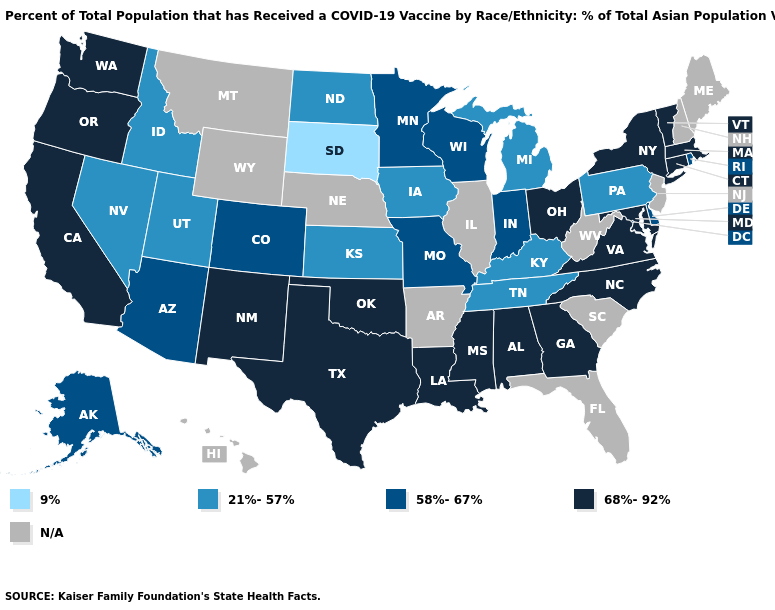Name the states that have a value in the range N/A?
Quick response, please. Arkansas, Florida, Hawaii, Illinois, Maine, Montana, Nebraska, New Hampshire, New Jersey, South Carolina, West Virginia, Wyoming. What is the value of Michigan?
Be succinct. 21%-57%. Which states have the lowest value in the USA?
Keep it brief. South Dakota. Name the states that have a value in the range 9%?
Concise answer only. South Dakota. What is the lowest value in the USA?
Concise answer only. 9%. Does New Mexico have the highest value in the USA?
Concise answer only. Yes. What is the highest value in the Northeast ?
Keep it brief. 68%-92%. Name the states that have a value in the range 68%-92%?
Short answer required. Alabama, California, Connecticut, Georgia, Louisiana, Maryland, Massachusetts, Mississippi, New Mexico, New York, North Carolina, Ohio, Oklahoma, Oregon, Texas, Vermont, Virginia, Washington. Name the states that have a value in the range 58%-67%?
Be succinct. Alaska, Arizona, Colorado, Delaware, Indiana, Minnesota, Missouri, Rhode Island, Wisconsin. What is the highest value in the South ?
Concise answer only. 68%-92%. Which states have the lowest value in the USA?
Keep it brief. South Dakota. What is the value of Oregon?
Give a very brief answer. 68%-92%. Does Rhode Island have the lowest value in the USA?
Write a very short answer. No. What is the value of Virginia?
Short answer required. 68%-92%. 